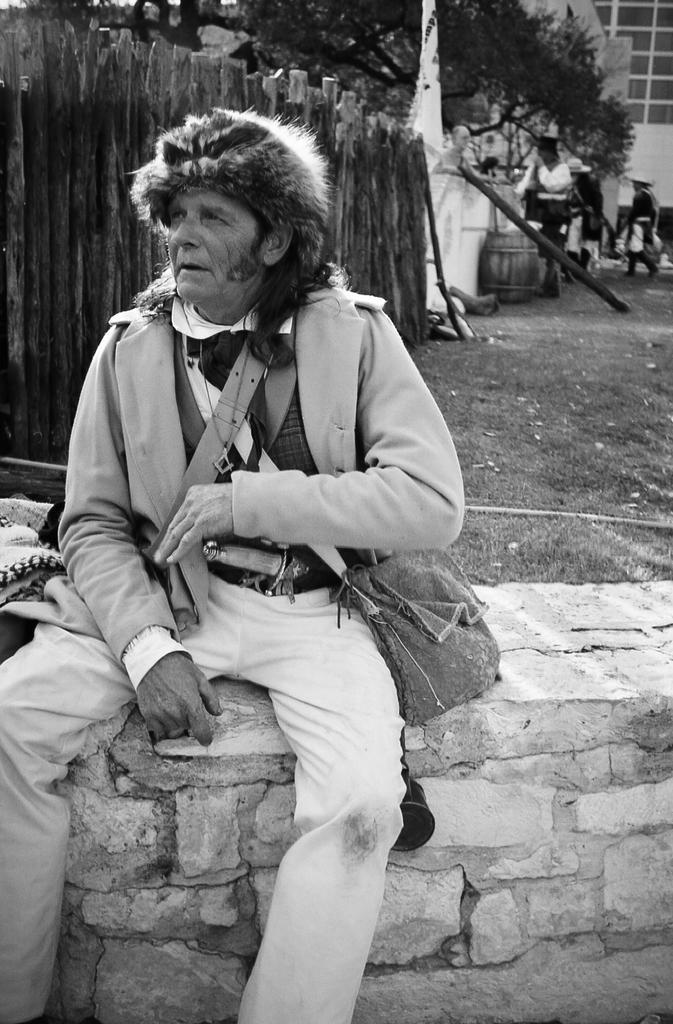Can you describe this image briefly? In the image we can see a man wearing clothes, neck chain and a cap. This is a handbag, grass, wooden fence, building and a tree. This man is sitting, there are even other people, this is a container. 